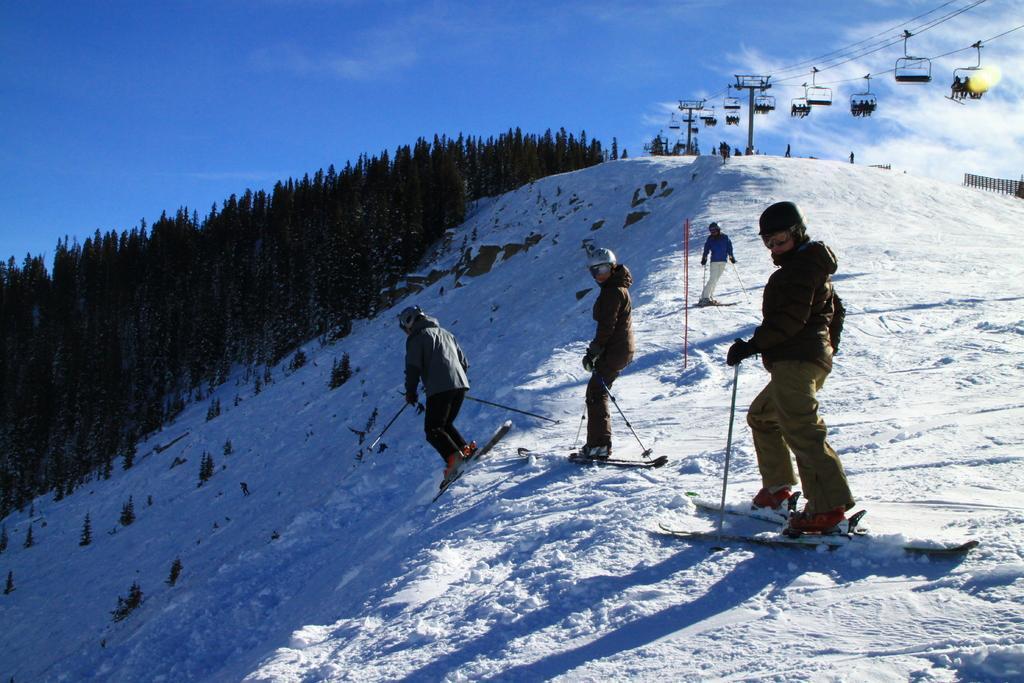Describe this image in one or two sentences. In this image we can see some people standing on the snowboards and holding ski sticks, ropeways, trees, at the top we can see the sky. 